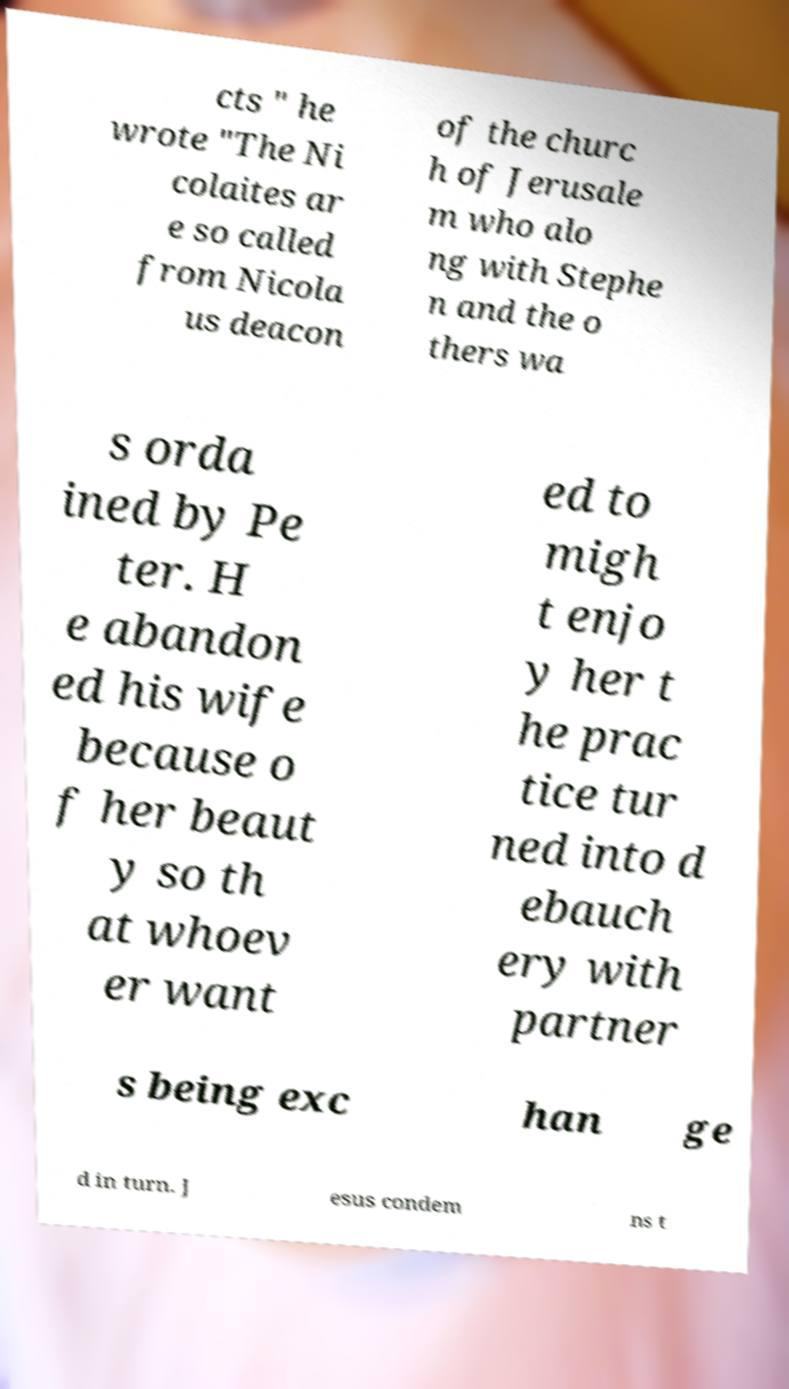Can you read and provide the text displayed in the image?This photo seems to have some interesting text. Can you extract and type it out for me? cts " he wrote "The Ni colaites ar e so called from Nicola us deacon of the churc h of Jerusale m who alo ng with Stephe n and the o thers wa s orda ined by Pe ter. H e abandon ed his wife because o f her beaut y so th at whoev er want ed to migh t enjo y her t he prac tice tur ned into d ebauch ery with partner s being exc han ge d in turn. J esus condem ns t 